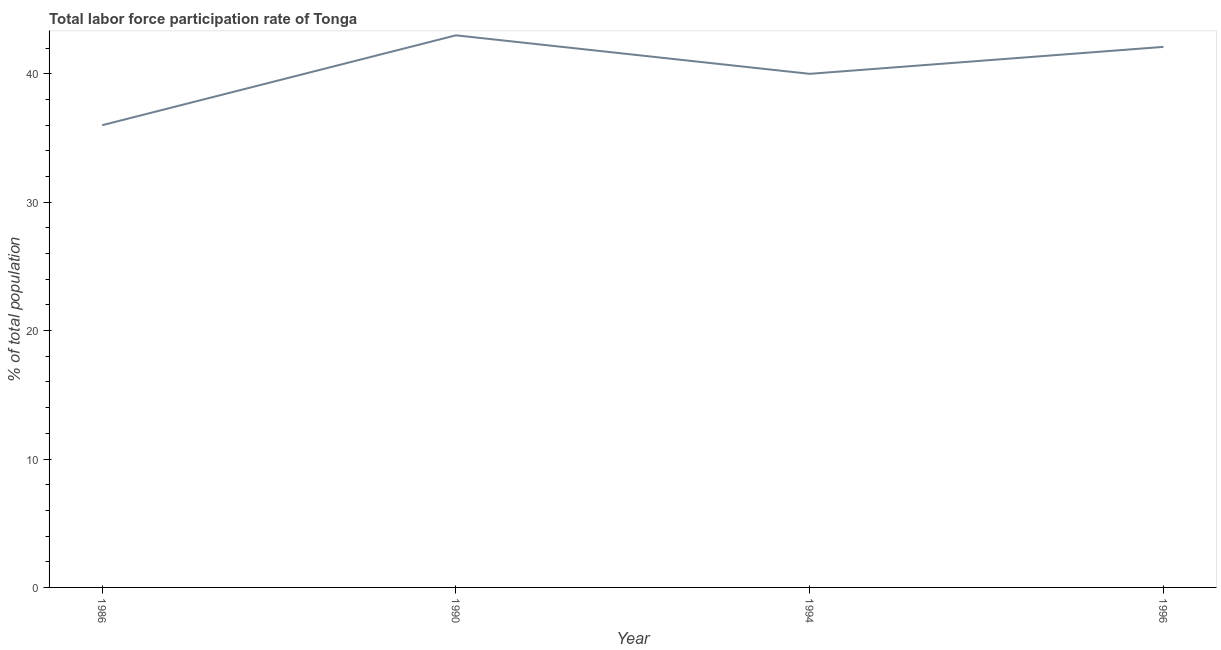What is the total labor force participation rate in 1996?
Provide a succinct answer. 42.1. Across all years, what is the maximum total labor force participation rate?
Ensure brevity in your answer.  43. In which year was the total labor force participation rate minimum?
Provide a succinct answer. 1986. What is the sum of the total labor force participation rate?
Ensure brevity in your answer.  161.1. What is the difference between the total labor force participation rate in 1994 and 1996?
Give a very brief answer. -2.1. What is the average total labor force participation rate per year?
Your answer should be very brief. 40.27. What is the median total labor force participation rate?
Give a very brief answer. 41.05. In how many years, is the total labor force participation rate greater than 38 %?
Make the answer very short. 3. What is the ratio of the total labor force participation rate in 1994 to that in 1996?
Your answer should be compact. 0.95. Is the total labor force participation rate in 1990 less than that in 1994?
Ensure brevity in your answer.  No. What is the difference between the highest and the second highest total labor force participation rate?
Provide a succinct answer. 0.9. Is the sum of the total labor force participation rate in 1986 and 1996 greater than the maximum total labor force participation rate across all years?
Keep it short and to the point. Yes. What is the difference between the highest and the lowest total labor force participation rate?
Your answer should be very brief. 7. In how many years, is the total labor force participation rate greater than the average total labor force participation rate taken over all years?
Your answer should be compact. 2. Does the total labor force participation rate monotonically increase over the years?
Provide a short and direct response. No. How many lines are there?
Give a very brief answer. 1. How many years are there in the graph?
Provide a short and direct response. 4. Does the graph contain grids?
Keep it short and to the point. No. What is the title of the graph?
Ensure brevity in your answer.  Total labor force participation rate of Tonga. What is the label or title of the Y-axis?
Your answer should be very brief. % of total population. What is the % of total population in 1986?
Your answer should be compact. 36. What is the % of total population in 1996?
Keep it short and to the point. 42.1. What is the difference between the % of total population in 1986 and 1994?
Offer a terse response. -4. What is the difference between the % of total population in 1994 and 1996?
Your answer should be very brief. -2.1. What is the ratio of the % of total population in 1986 to that in 1990?
Your answer should be very brief. 0.84. What is the ratio of the % of total population in 1986 to that in 1994?
Your response must be concise. 0.9. What is the ratio of the % of total population in 1986 to that in 1996?
Keep it short and to the point. 0.85. What is the ratio of the % of total population in 1990 to that in 1994?
Keep it short and to the point. 1.07. 